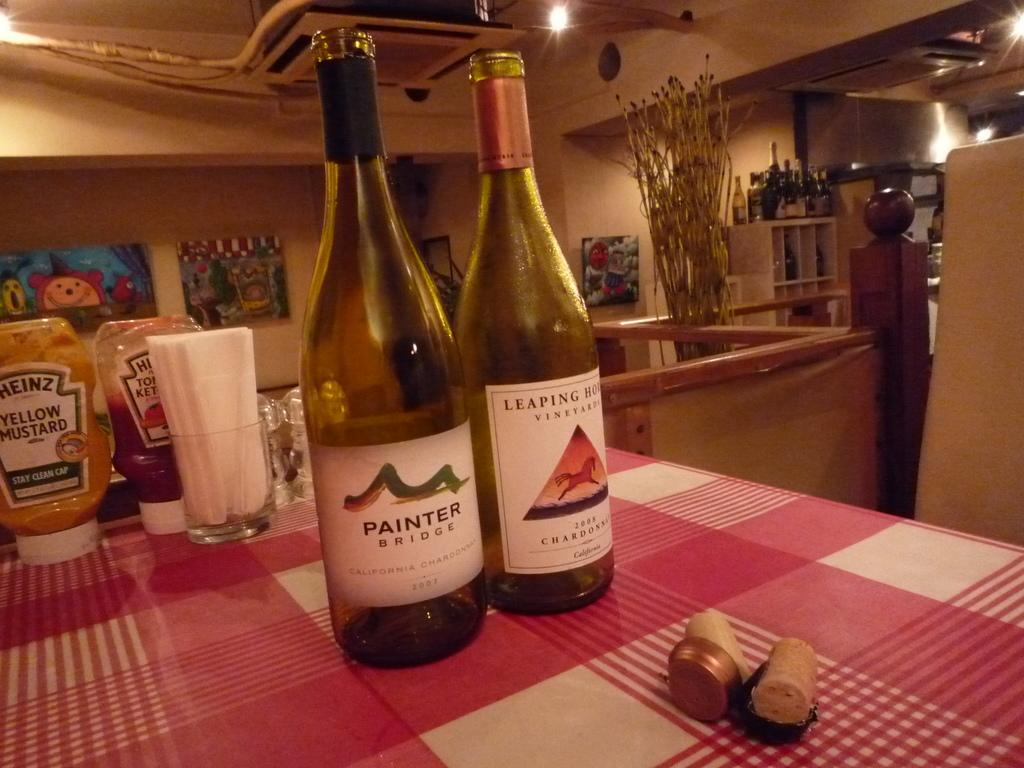<image>
Create a compact narrative representing the image presented. A bottle of Painter Bridge chardonnay sits on a plaid tablecloth. 